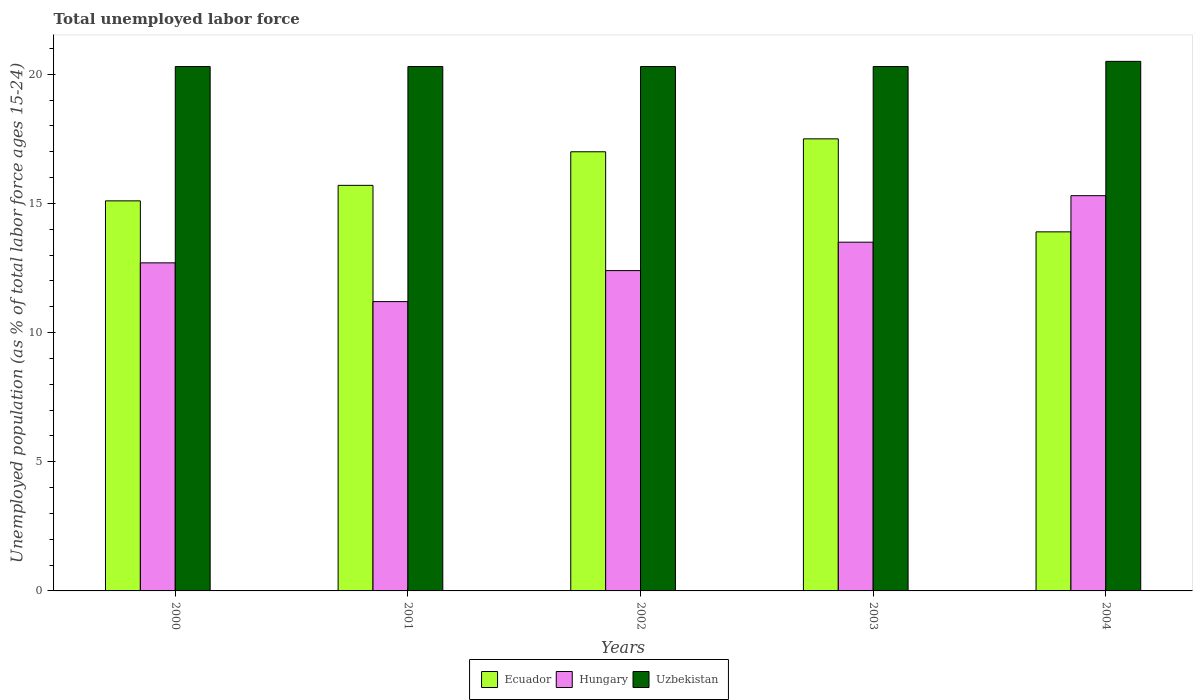How many groups of bars are there?
Provide a short and direct response. 5. How many bars are there on the 3rd tick from the left?
Provide a succinct answer. 3. What is the percentage of unemployed population in in Hungary in 2001?
Ensure brevity in your answer.  11.2. Across all years, what is the maximum percentage of unemployed population in in Ecuador?
Give a very brief answer. 17.5. Across all years, what is the minimum percentage of unemployed population in in Uzbekistan?
Ensure brevity in your answer.  20.3. What is the total percentage of unemployed population in in Ecuador in the graph?
Keep it short and to the point. 79.2. What is the difference between the percentage of unemployed population in in Hungary in 2001 and that in 2002?
Give a very brief answer. -1.2. What is the average percentage of unemployed population in in Ecuador per year?
Give a very brief answer. 15.84. In the year 2001, what is the difference between the percentage of unemployed population in in Uzbekistan and percentage of unemployed population in in Ecuador?
Give a very brief answer. 4.6. What is the ratio of the percentage of unemployed population in in Uzbekistan in 2001 to that in 2004?
Offer a terse response. 0.99. Is the percentage of unemployed population in in Ecuador in 2001 less than that in 2004?
Provide a short and direct response. No. What is the difference between the highest and the lowest percentage of unemployed population in in Ecuador?
Keep it short and to the point. 3.6. What does the 3rd bar from the left in 2000 represents?
Your answer should be very brief. Uzbekistan. What does the 3rd bar from the right in 2003 represents?
Offer a terse response. Ecuador. What is the difference between two consecutive major ticks on the Y-axis?
Offer a terse response. 5. Does the graph contain any zero values?
Give a very brief answer. No. What is the title of the graph?
Provide a short and direct response. Total unemployed labor force. What is the label or title of the X-axis?
Keep it short and to the point. Years. What is the label or title of the Y-axis?
Your answer should be compact. Unemployed population (as % of total labor force ages 15-24). What is the Unemployed population (as % of total labor force ages 15-24) in Ecuador in 2000?
Make the answer very short. 15.1. What is the Unemployed population (as % of total labor force ages 15-24) of Hungary in 2000?
Make the answer very short. 12.7. What is the Unemployed population (as % of total labor force ages 15-24) in Uzbekistan in 2000?
Keep it short and to the point. 20.3. What is the Unemployed population (as % of total labor force ages 15-24) in Ecuador in 2001?
Provide a succinct answer. 15.7. What is the Unemployed population (as % of total labor force ages 15-24) in Hungary in 2001?
Provide a short and direct response. 11.2. What is the Unemployed population (as % of total labor force ages 15-24) of Uzbekistan in 2001?
Make the answer very short. 20.3. What is the Unemployed population (as % of total labor force ages 15-24) in Ecuador in 2002?
Offer a terse response. 17. What is the Unemployed population (as % of total labor force ages 15-24) in Hungary in 2002?
Offer a very short reply. 12.4. What is the Unemployed population (as % of total labor force ages 15-24) in Uzbekistan in 2002?
Keep it short and to the point. 20.3. What is the Unemployed population (as % of total labor force ages 15-24) in Ecuador in 2003?
Your answer should be compact. 17.5. What is the Unemployed population (as % of total labor force ages 15-24) of Hungary in 2003?
Provide a succinct answer. 13.5. What is the Unemployed population (as % of total labor force ages 15-24) of Uzbekistan in 2003?
Offer a terse response. 20.3. What is the Unemployed population (as % of total labor force ages 15-24) of Ecuador in 2004?
Provide a succinct answer. 13.9. What is the Unemployed population (as % of total labor force ages 15-24) of Hungary in 2004?
Provide a short and direct response. 15.3. What is the Unemployed population (as % of total labor force ages 15-24) of Uzbekistan in 2004?
Give a very brief answer. 20.5. Across all years, what is the maximum Unemployed population (as % of total labor force ages 15-24) in Ecuador?
Give a very brief answer. 17.5. Across all years, what is the maximum Unemployed population (as % of total labor force ages 15-24) of Hungary?
Ensure brevity in your answer.  15.3. Across all years, what is the minimum Unemployed population (as % of total labor force ages 15-24) of Ecuador?
Provide a succinct answer. 13.9. Across all years, what is the minimum Unemployed population (as % of total labor force ages 15-24) of Hungary?
Offer a very short reply. 11.2. Across all years, what is the minimum Unemployed population (as % of total labor force ages 15-24) in Uzbekistan?
Ensure brevity in your answer.  20.3. What is the total Unemployed population (as % of total labor force ages 15-24) of Ecuador in the graph?
Keep it short and to the point. 79.2. What is the total Unemployed population (as % of total labor force ages 15-24) in Hungary in the graph?
Make the answer very short. 65.1. What is the total Unemployed population (as % of total labor force ages 15-24) in Uzbekistan in the graph?
Your answer should be very brief. 101.7. What is the difference between the Unemployed population (as % of total labor force ages 15-24) in Ecuador in 2000 and that in 2001?
Your answer should be very brief. -0.6. What is the difference between the Unemployed population (as % of total labor force ages 15-24) of Hungary in 2000 and that in 2001?
Your answer should be very brief. 1.5. What is the difference between the Unemployed population (as % of total labor force ages 15-24) of Uzbekistan in 2000 and that in 2001?
Provide a short and direct response. 0. What is the difference between the Unemployed population (as % of total labor force ages 15-24) in Hungary in 2000 and that in 2002?
Give a very brief answer. 0.3. What is the difference between the Unemployed population (as % of total labor force ages 15-24) in Hungary in 2000 and that in 2004?
Your answer should be very brief. -2.6. What is the difference between the Unemployed population (as % of total labor force ages 15-24) in Ecuador in 2001 and that in 2002?
Give a very brief answer. -1.3. What is the difference between the Unemployed population (as % of total labor force ages 15-24) of Uzbekistan in 2001 and that in 2002?
Ensure brevity in your answer.  0. What is the difference between the Unemployed population (as % of total labor force ages 15-24) in Ecuador in 2001 and that in 2003?
Provide a short and direct response. -1.8. What is the difference between the Unemployed population (as % of total labor force ages 15-24) of Uzbekistan in 2001 and that in 2003?
Your response must be concise. 0. What is the difference between the Unemployed population (as % of total labor force ages 15-24) in Uzbekistan in 2002 and that in 2003?
Keep it short and to the point. 0. What is the difference between the Unemployed population (as % of total labor force ages 15-24) of Ecuador in 2002 and that in 2004?
Provide a short and direct response. 3.1. What is the difference between the Unemployed population (as % of total labor force ages 15-24) of Uzbekistan in 2002 and that in 2004?
Give a very brief answer. -0.2. What is the difference between the Unemployed population (as % of total labor force ages 15-24) in Uzbekistan in 2003 and that in 2004?
Provide a succinct answer. -0.2. What is the difference between the Unemployed population (as % of total labor force ages 15-24) in Hungary in 2000 and the Unemployed population (as % of total labor force ages 15-24) in Uzbekistan in 2001?
Keep it short and to the point. -7.6. What is the difference between the Unemployed population (as % of total labor force ages 15-24) in Ecuador in 2000 and the Unemployed population (as % of total labor force ages 15-24) in Hungary in 2002?
Ensure brevity in your answer.  2.7. What is the difference between the Unemployed population (as % of total labor force ages 15-24) in Ecuador in 2000 and the Unemployed population (as % of total labor force ages 15-24) in Uzbekistan in 2002?
Offer a terse response. -5.2. What is the difference between the Unemployed population (as % of total labor force ages 15-24) of Hungary in 2000 and the Unemployed population (as % of total labor force ages 15-24) of Uzbekistan in 2003?
Your response must be concise. -7.6. What is the difference between the Unemployed population (as % of total labor force ages 15-24) of Ecuador in 2000 and the Unemployed population (as % of total labor force ages 15-24) of Uzbekistan in 2004?
Offer a very short reply. -5.4. What is the difference between the Unemployed population (as % of total labor force ages 15-24) of Hungary in 2001 and the Unemployed population (as % of total labor force ages 15-24) of Uzbekistan in 2002?
Make the answer very short. -9.1. What is the difference between the Unemployed population (as % of total labor force ages 15-24) in Ecuador in 2001 and the Unemployed population (as % of total labor force ages 15-24) in Uzbekistan in 2003?
Ensure brevity in your answer.  -4.6. What is the difference between the Unemployed population (as % of total labor force ages 15-24) in Hungary in 2001 and the Unemployed population (as % of total labor force ages 15-24) in Uzbekistan in 2003?
Offer a very short reply. -9.1. What is the difference between the Unemployed population (as % of total labor force ages 15-24) of Hungary in 2001 and the Unemployed population (as % of total labor force ages 15-24) of Uzbekistan in 2004?
Give a very brief answer. -9.3. What is the difference between the Unemployed population (as % of total labor force ages 15-24) in Ecuador in 2002 and the Unemployed population (as % of total labor force ages 15-24) in Hungary in 2003?
Make the answer very short. 3.5. What is the difference between the Unemployed population (as % of total labor force ages 15-24) of Ecuador in 2002 and the Unemployed population (as % of total labor force ages 15-24) of Uzbekistan in 2003?
Your answer should be compact. -3.3. What is the difference between the Unemployed population (as % of total labor force ages 15-24) of Hungary in 2002 and the Unemployed population (as % of total labor force ages 15-24) of Uzbekistan in 2003?
Your answer should be compact. -7.9. What is the difference between the Unemployed population (as % of total labor force ages 15-24) in Ecuador in 2003 and the Unemployed population (as % of total labor force ages 15-24) in Hungary in 2004?
Provide a short and direct response. 2.2. What is the difference between the Unemployed population (as % of total labor force ages 15-24) of Ecuador in 2003 and the Unemployed population (as % of total labor force ages 15-24) of Uzbekistan in 2004?
Your response must be concise. -3. What is the average Unemployed population (as % of total labor force ages 15-24) of Ecuador per year?
Your answer should be compact. 15.84. What is the average Unemployed population (as % of total labor force ages 15-24) in Hungary per year?
Your answer should be compact. 13.02. What is the average Unemployed population (as % of total labor force ages 15-24) in Uzbekistan per year?
Your response must be concise. 20.34. In the year 2000, what is the difference between the Unemployed population (as % of total labor force ages 15-24) of Ecuador and Unemployed population (as % of total labor force ages 15-24) of Uzbekistan?
Ensure brevity in your answer.  -5.2. In the year 2000, what is the difference between the Unemployed population (as % of total labor force ages 15-24) of Hungary and Unemployed population (as % of total labor force ages 15-24) of Uzbekistan?
Ensure brevity in your answer.  -7.6. In the year 2001, what is the difference between the Unemployed population (as % of total labor force ages 15-24) of Ecuador and Unemployed population (as % of total labor force ages 15-24) of Uzbekistan?
Offer a very short reply. -4.6. In the year 2002, what is the difference between the Unemployed population (as % of total labor force ages 15-24) in Ecuador and Unemployed population (as % of total labor force ages 15-24) in Hungary?
Provide a short and direct response. 4.6. In the year 2002, what is the difference between the Unemployed population (as % of total labor force ages 15-24) in Ecuador and Unemployed population (as % of total labor force ages 15-24) in Uzbekistan?
Keep it short and to the point. -3.3. In the year 2003, what is the difference between the Unemployed population (as % of total labor force ages 15-24) of Ecuador and Unemployed population (as % of total labor force ages 15-24) of Uzbekistan?
Your response must be concise. -2.8. In the year 2004, what is the difference between the Unemployed population (as % of total labor force ages 15-24) in Hungary and Unemployed population (as % of total labor force ages 15-24) in Uzbekistan?
Your answer should be compact. -5.2. What is the ratio of the Unemployed population (as % of total labor force ages 15-24) in Ecuador in 2000 to that in 2001?
Your answer should be very brief. 0.96. What is the ratio of the Unemployed population (as % of total labor force ages 15-24) in Hungary in 2000 to that in 2001?
Ensure brevity in your answer.  1.13. What is the ratio of the Unemployed population (as % of total labor force ages 15-24) of Ecuador in 2000 to that in 2002?
Keep it short and to the point. 0.89. What is the ratio of the Unemployed population (as % of total labor force ages 15-24) of Hungary in 2000 to that in 2002?
Provide a short and direct response. 1.02. What is the ratio of the Unemployed population (as % of total labor force ages 15-24) in Uzbekistan in 2000 to that in 2002?
Offer a terse response. 1. What is the ratio of the Unemployed population (as % of total labor force ages 15-24) of Ecuador in 2000 to that in 2003?
Keep it short and to the point. 0.86. What is the ratio of the Unemployed population (as % of total labor force ages 15-24) in Hungary in 2000 to that in 2003?
Your answer should be compact. 0.94. What is the ratio of the Unemployed population (as % of total labor force ages 15-24) in Ecuador in 2000 to that in 2004?
Offer a very short reply. 1.09. What is the ratio of the Unemployed population (as % of total labor force ages 15-24) in Hungary in 2000 to that in 2004?
Give a very brief answer. 0.83. What is the ratio of the Unemployed population (as % of total labor force ages 15-24) of Uzbekistan in 2000 to that in 2004?
Ensure brevity in your answer.  0.99. What is the ratio of the Unemployed population (as % of total labor force ages 15-24) of Ecuador in 2001 to that in 2002?
Your answer should be compact. 0.92. What is the ratio of the Unemployed population (as % of total labor force ages 15-24) in Hungary in 2001 to that in 2002?
Provide a succinct answer. 0.9. What is the ratio of the Unemployed population (as % of total labor force ages 15-24) of Uzbekistan in 2001 to that in 2002?
Provide a short and direct response. 1. What is the ratio of the Unemployed population (as % of total labor force ages 15-24) of Ecuador in 2001 to that in 2003?
Offer a terse response. 0.9. What is the ratio of the Unemployed population (as % of total labor force ages 15-24) of Hungary in 2001 to that in 2003?
Your response must be concise. 0.83. What is the ratio of the Unemployed population (as % of total labor force ages 15-24) of Uzbekistan in 2001 to that in 2003?
Offer a terse response. 1. What is the ratio of the Unemployed population (as % of total labor force ages 15-24) of Ecuador in 2001 to that in 2004?
Provide a short and direct response. 1.13. What is the ratio of the Unemployed population (as % of total labor force ages 15-24) in Hungary in 2001 to that in 2004?
Your response must be concise. 0.73. What is the ratio of the Unemployed population (as % of total labor force ages 15-24) of Uzbekistan in 2001 to that in 2004?
Keep it short and to the point. 0.99. What is the ratio of the Unemployed population (as % of total labor force ages 15-24) of Ecuador in 2002 to that in 2003?
Provide a short and direct response. 0.97. What is the ratio of the Unemployed population (as % of total labor force ages 15-24) of Hungary in 2002 to that in 2003?
Offer a very short reply. 0.92. What is the ratio of the Unemployed population (as % of total labor force ages 15-24) of Ecuador in 2002 to that in 2004?
Your response must be concise. 1.22. What is the ratio of the Unemployed population (as % of total labor force ages 15-24) of Hungary in 2002 to that in 2004?
Ensure brevity in your answer.  0.81. What is the ratio of the Unemployed population (as % of total labor force ages 15-24) in Uzbekistan in 2002 to that in 2004?
Make the answer very short. 0.99. What is the ratio of the Unemployed population (as % of total labor force ages 15-24) of Ecuador in 2003 to that in 2004?
Your response must be concise. 1.26. What is the ratio of the Unemployed population (as % of total labor force ages 15-24) of Hungary in 2003 to that in 2004?
Provide a succinct answer. 0.88. What is the ratio of the Unemployed population (as % of total labor force ages 15-24) of Uzbekistan in 2003 to that in 2004?
Provide a short and direct response. 0.99. What is the difference between the highest and the second highest Unemployed population (as % of total labor force ages 15-24) of Ecuador?
Keep it short and to the point. 0.5. What is the difference between the highest and the second highest Unemployed population (as % of total labor force ages 15-24) of Uzbekistan?
Provide a succinct answer. 0.2. What is the difference between the highest and the lowest Unemployed population (as % of total labor force ages 15-24) in Hungary?
Offer a terse response. 4.1. 